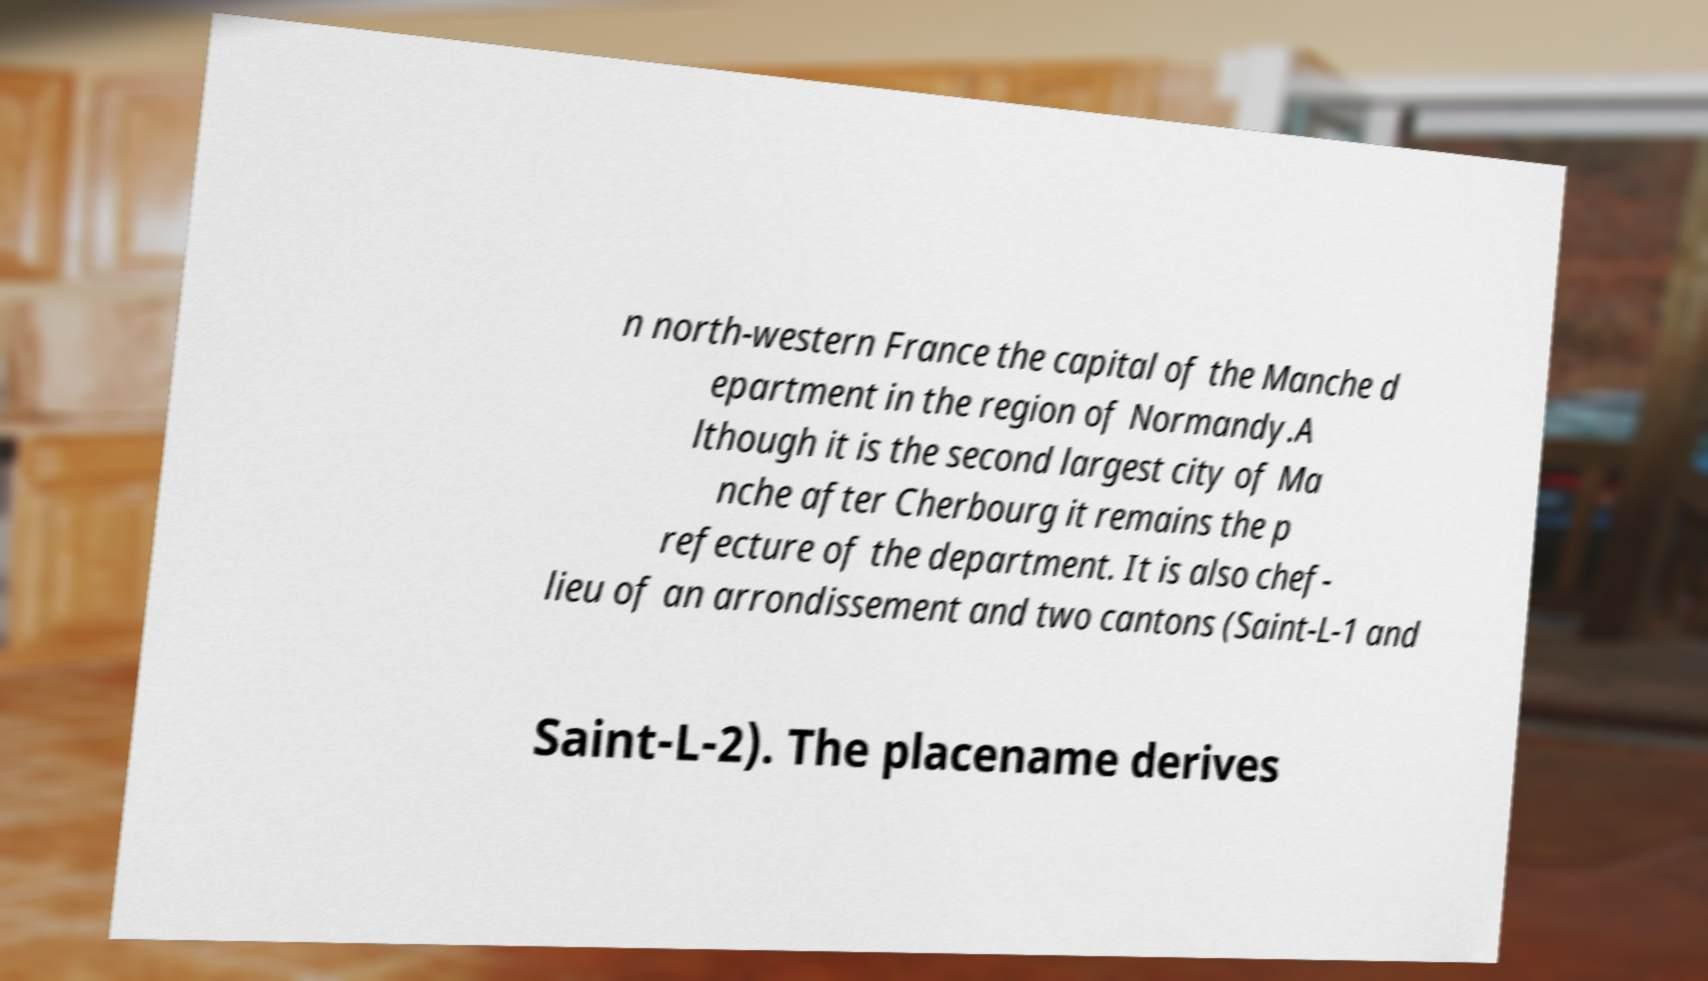Please identify and transcribe the text found in this image. n north-western France the capital of the Manche d epartment in the region of Normandy.A lthough it is the second largest city of Ma nche after Cherbourg it remains the p refecture of the department. It is also chef- lieu of an arrondissement and two cantons (Saint-L-1 and Saint-L-2). The placename derives 